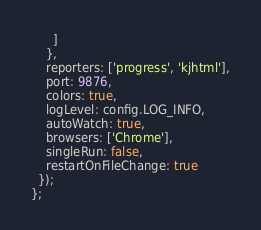<code> <loc_0><loc_0><loc_500><loc_500><_JavaScript_>      ]
    },
    reporters: ['progress', 'kjhtml'],
    port: 9876,
    colors: true,
    logLevel: config.LOG_INFO,
    autoWatch: true,
    browsers: ['Chrome'],
    singleRun: false,
    restartOnFileChange: true
  });
};
</code> 